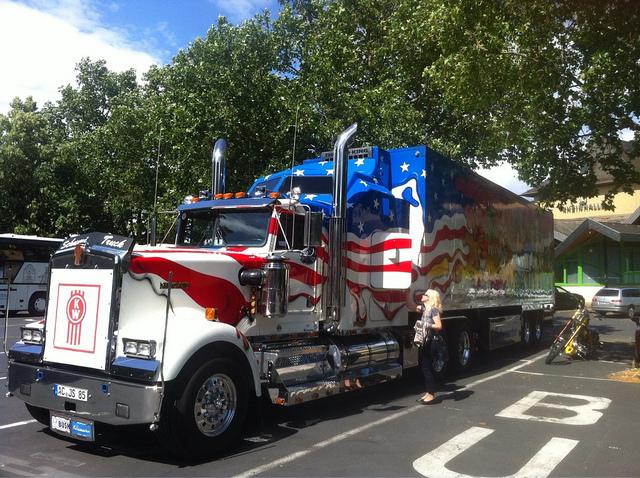Does the truck have a US license plate?
Write a very short answer. No. What country's flag do these colors represent?
Answer briefly. Usa. What kind of truck is this?
Keep it brief. Semi. 